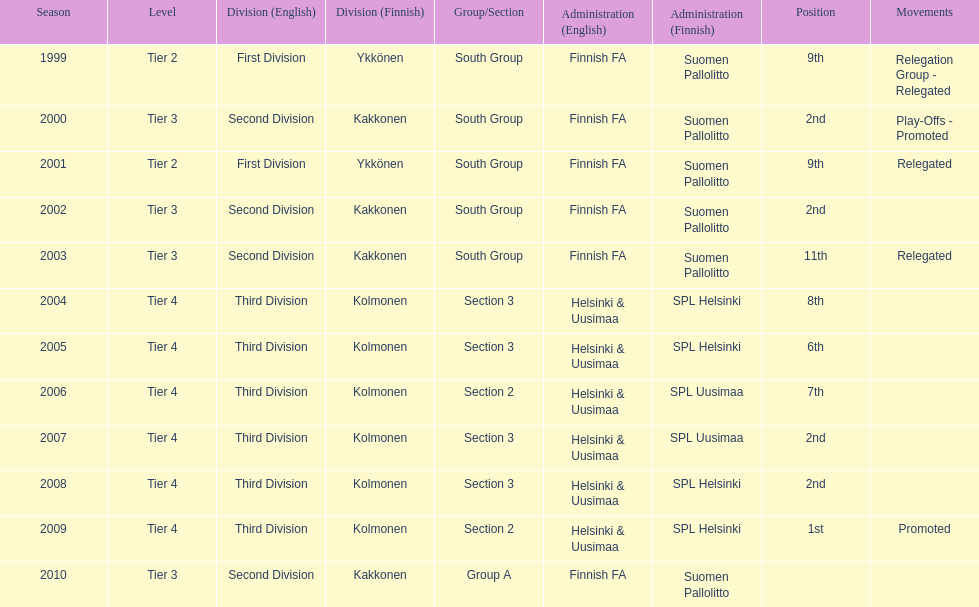How many tiers had more than one relegated movement? 1. Give me the full table as a dictionary. {'header': ['Season', 'Level', 'Division (English)', 'Division (Finnish)', 'Group/Section', 'Administration (English)', 'Administration (Finnish)', 'Position', 'Movements'], 'rows': [['1999', 'Tier 2', 'First Division', 'Ykkönen', 'South Group', 'Finnish FA', 'Suomen Pallolitto', '9th', 'Relegation Group - Relegated'], ['2000', 'Tier 3', 'Second Division', 'Kakkonen', 'South Group', 'Finnish FA', 'Suomen Pallolitto', '2nd', 'Play-Offs - Promoted'], ['2001', 'Tier 2', 'First Division', 'Ykkönen', 'South Group', 'Finnish FA', 'Suomen Pallolitto', '9th', 'Relegated'], ['2002', 'Tier 3', 'Second Division', 'Kakkonen', 'South Group', 'Finnish FA', 'Suomen Pallolitto', '2nd', ''], ['2003', 'Tier 3', 'Second Division', 'Kakkonen', 'South Group', 'Finnish FA', 'Suomen Pallolitto', '11th', 'Relegated'], ['2004', 'Tier 4', 'Third Division', 'Kolmonen', 'Section 3', 'Helsinki & Uusimaa', 'SPL Helsinki', '8th', ''], ['2005', 'Tier 4', 'Third Division', 'Kolmonen', 'Section 3', 'Helsinki & Uusimaa', 'SPL Helsinki', '6th', ''], ['2006', 'Tier 4', 'Third Division', 'Kolmonen', 'Section 2', 'Helsinki & Uusimaa', 'SPL Uusimaa', '7th', ''], ['2007', 'Tier 4', 'Third Division', 'Kolmonen', 'Section 3', 'Helsinki & Uusimaa', 'SPL Uusimaa', '2nd', ''], ['2008', 'Tier 4', 'Third Division', 'Kolmonen', 'Section 3', 'Helsinki & Uusimaa', 'SPL Helsinki', '2nd', ''], ['2009', 'Tier 4', 'Third Division', 'Kolmonen', 'Section 2', 'Helsinki & Uusimaa', 'SPL Helsinki', '1st', 'Promoted'], ['2010', 'Tier 3', 'Second Division', 'Kakkonen', 'Group A', 'Finnish FA', 'Suomen Pallolitto', '', '']]} 